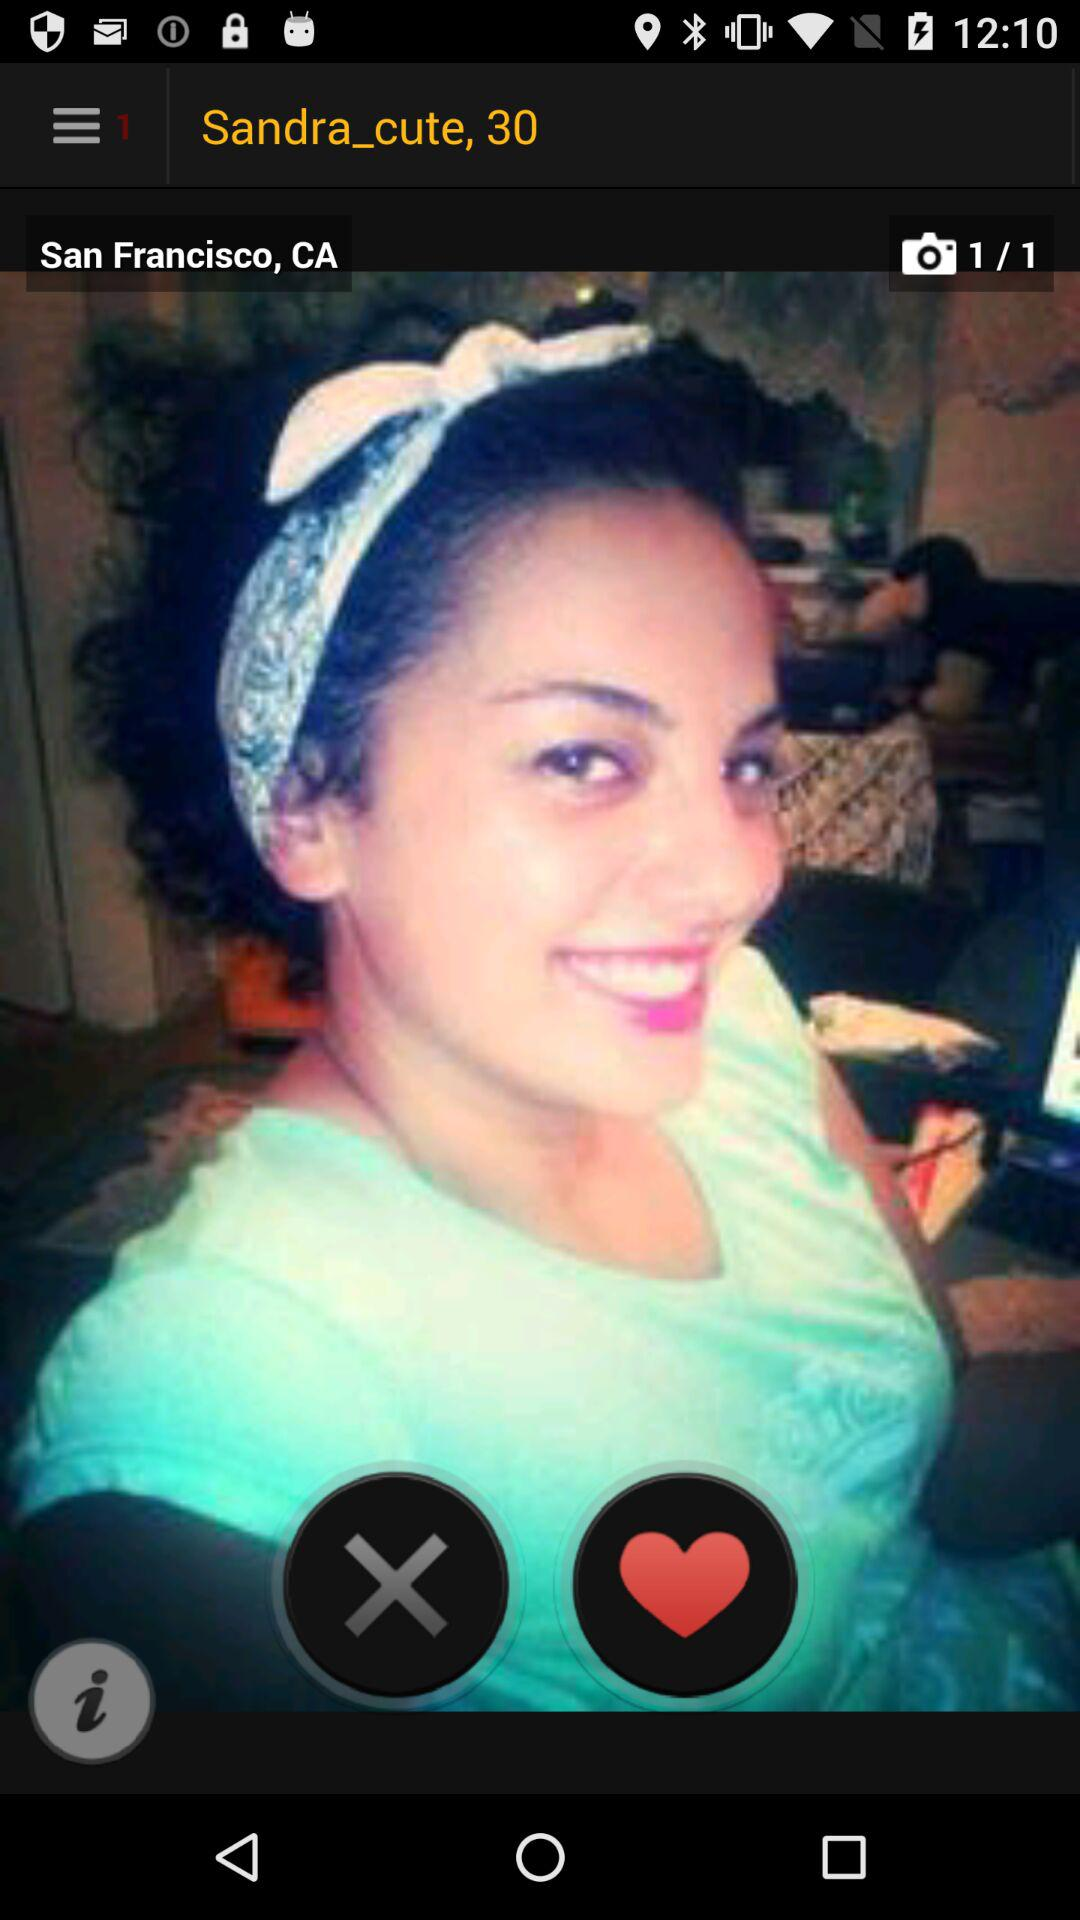What is the selected country? The selected country is San Francisco, CA. 